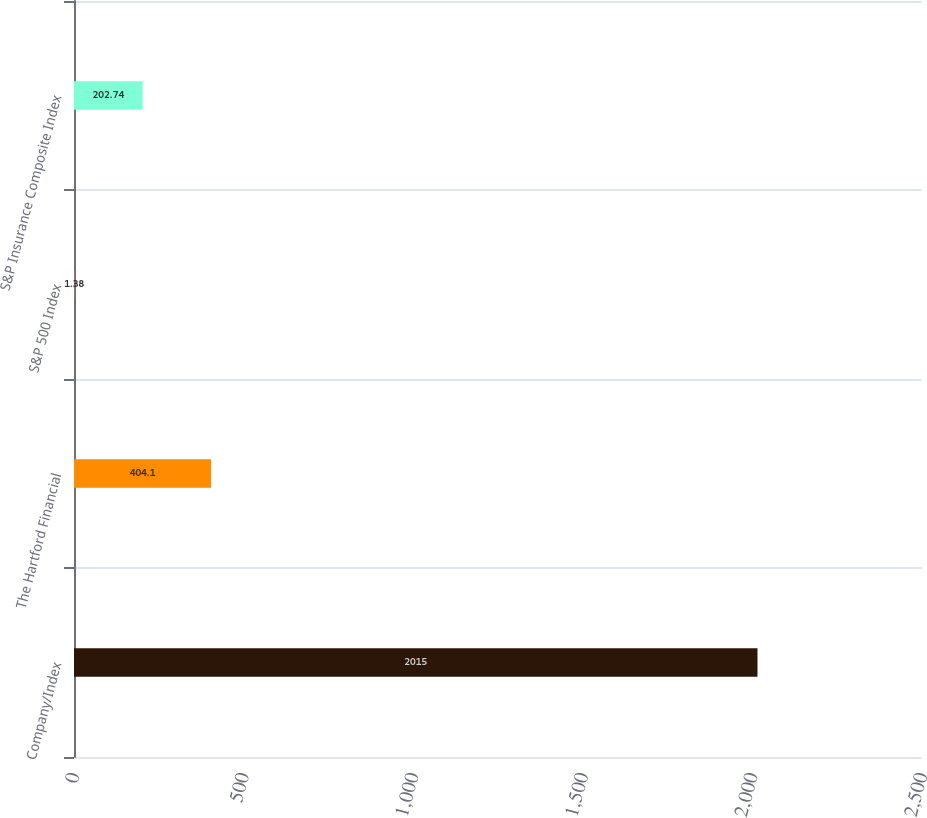<chart> <loc_0><loc_0><loc_500><loc_500><bar_chart><fcel>Company/Index<fcel>The Hartford Financial<fcel>S&P 500 Index<fcel>S&P Insurance Composite Index<nl><fcel>2015<fcel>404.1<fcel>1.38<fcel>202.74<nl></chart> 